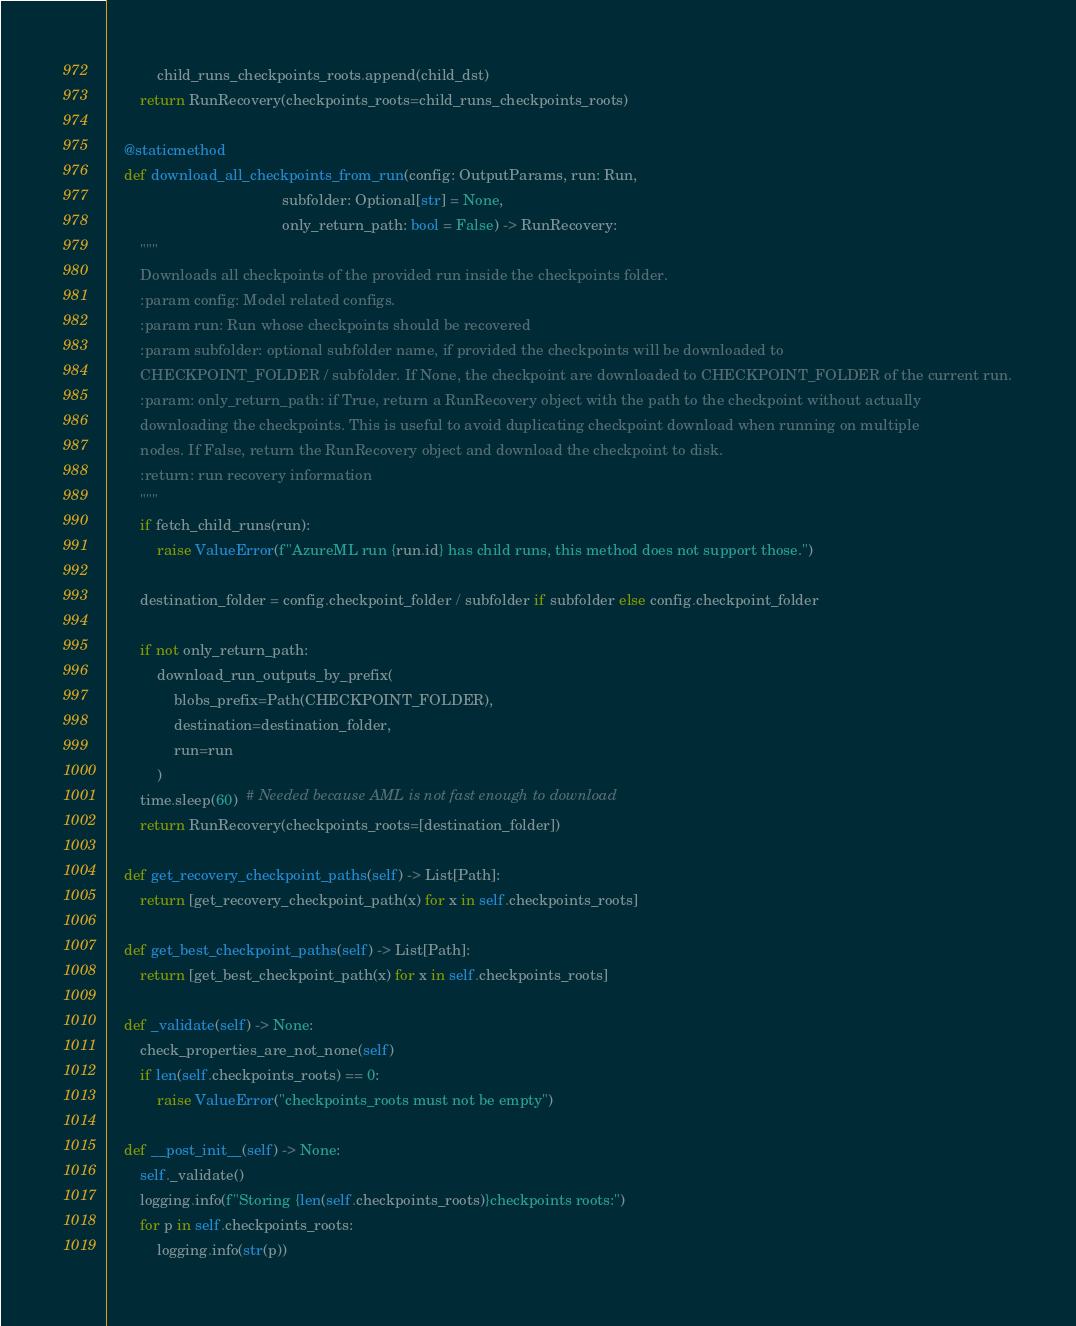Convert code to text. <code><loc_0><loc_0><loc_500><loc_500><_Python_>            child_runs_checkpoints_roots.append(child_dst)
        return RunRecovery(checkpoints_roots=child_runs_checkpoints_roots)

    @staticmethod
    def download_all_checkpoints_from_run(config: OutputParams, run: Run,
                                          subfolder: Optional[str] = None,
                                          only_return_path: bool = False) -> RunRecovery:
        """
        Downloads all checkpoints of the provided run inside the checkpoints folder.
        :param config: Model related configs.
        :param run: Run whose checkpoints should be recovered
        :param subfolder: optional subfolder name, if provided the checkpoints will be downloaded to
        CHECKPOINT_FOLDER / subfolder. If None, the checkpoint are downloaded to CHECKPOINT_FOLDER of the current run.
        :param: only_return_path: if True, return a RunRecovery object with the path to the checkpoint without actually
        downloading the checkpoints. This is useful to avoid duplicating checkpoint download when running on multiple
        nodes. If False, return the RunRecovery object and download the checkpoint to disk.
        :return: run recovery information
        """
        if fetch_child_runs(run):
            raise ValueError(f"AzureML run {run.id} has child runs, this method does not support those.")

        destination_folder = config.checkpoint_folder / subfolder if subfolder else config.checkpoint_folder

        if not only_return_path:
            download_run_outputs_by_prefix(
                blobs_prefix=Path(CHECKPOINT_FOLDER),
                destination=destination_folder,
                run=run
            )
        time.sleep(60)  # Needed because AML is not fast enough to download
        return RunRecovery(checkpoints_roots=[destination_folder])

    def get_recovery_checkpoint_paths(self) -> List[Path]:
        return [get_recovery_checkpoint_path(x) for x in self.checkpoints_roots]

    def get_best_checkpoint_paths(self) -> List[Path]:
        return [get_best_checkpoint_path(x) for x in self.checkpoints_roots]

    def _validate(self) -> None:
        check_properties_are_not_none(self)
        if len(self.checkpoints_roots) == 0:
            raise ValueError("checkpoints_roots must not be empty")

    def __post_init__(self) -> None:
        self._validate()
        logging.info(f"Storing {len(self.checkpoints_roots)}checkpoints roots:")
        for p in self.checkpoints_roots:
            logging.info(str(p))
</code> 